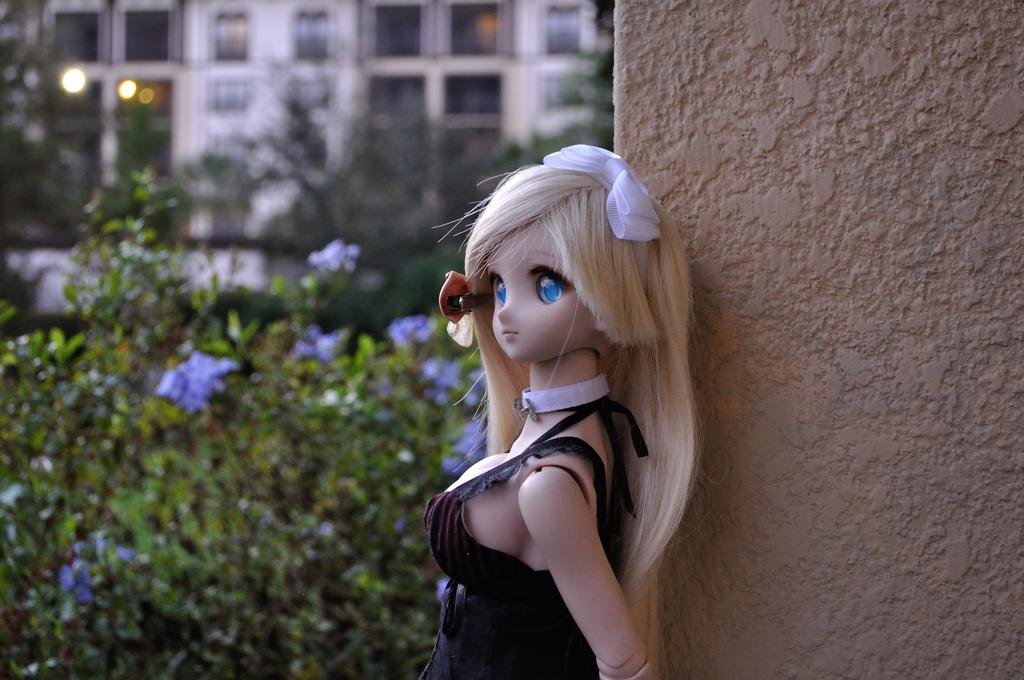What object is located on the right side of the image? There is a toy on the right side of the image. What is on the same side of the image as the toy? There is a wall on the right side of the image. What type of vegetation is on the left side of the image? There are plants on the left side of the image. What can be seen in the distance in the image? There are buildings visible in the background of the image. Can you see the mom driving a boat in the waves in the image? There is no mom, boat, or waves present in the image. 